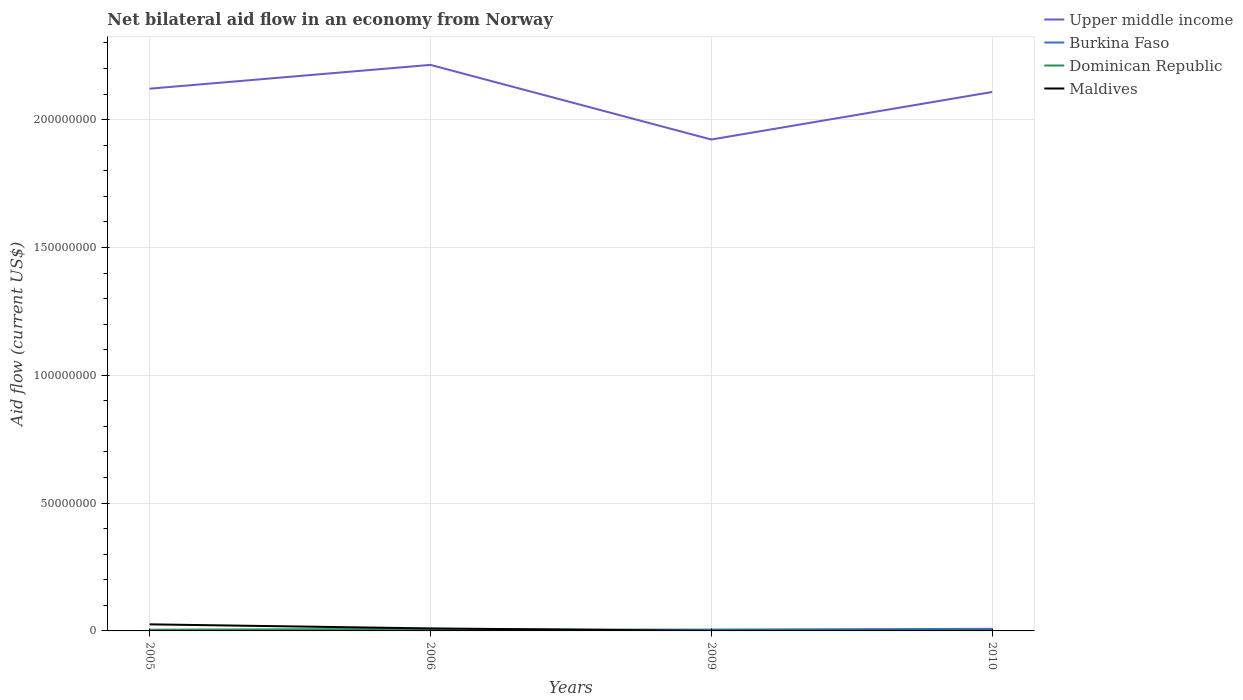How many different coloured lines are there?
Provide a short and direct response. 4. Does the line corresponding to Upper middle income intersect with the line corresponding to Dominican Republic?
Your response must be concise. No. Is the number of lines equal to the number of legend labels?
Keep it short and to the point. Yes. What is the difference between the highest and the second highest net bilateral aid flow in Maldives?
Make the answer very short. 2.56e+06. Is the net bilateral aid flow in Dominican Republic strictly greater than the net bilateral aid flow in Maldives over the years?
Keep it short and to the point. No. How many lines are there?
Give a very brief answer. 4. What is the difference between two consecutive major ticks on the Y-axis?
Give a very brief answer. 5.00e+07. Does the graph contain grids?
Your answer should be very brief. Yes. How many legend labels are there?
Offer a very short reply. 4. What is the title of the graph?
Offer a terse response. Net bilateral aid flow in an economy from Norway. What is the label or title of the Y-axis?
Your response must be concise. Aid flow (current US$). What is the Aid flow (current US$) of Upper middle income in 2005?
Ensure brevity in your answer.  2.12e+08. What is the Aid flow (current US$) of Dominican Republic in 2005?
Your answer should be compact. 4.80e+05. What is the Aid flow (current US$) of Maldives in 2005?
Keep it short and to the point. 2.57e+06. What is the Aid flow (current US$) of Upper middle income in 2006?
Provide a short and direct response. 2.21e+08. What is the Aid flow (current US$) in Burkina Faso in 2006?
Make the answer very short. 3.70e+05. What is the Aid flow (current US$) of Dominican Republic in 2006?
Your response must be concise. 7.90e+05. What is the Aid flow (current US$) of Maldives in 2006?
Keep it short and to the point. 9.80e+05. What is the Aid flow (current US$) in Upper middle income in 2009?
Keep it short and to the point. 1.92e+08. What is the Aid flow (current US$) in Burkina Faso in 2009?
Offer a terse response. 5.30e+05. What is the Aid flow (current US$) of Maldives in 2009?
Keep it short and to the point. 10000. What is the Aid flow (current US$) in Upper middle income in 2010?
Your response must be concise. 2.11e+08. What is the Aid flow (current US$) of Burkina Faso in 2010?
Provide a short and direct response. 8.20e+05. What is the Aid flow (current US$) of Dominican Republic in 2010?
Your response must be concise. 2.60e+05. What is the Aid flow (current US$) of Maldives in 2010?
Your response must be concise. 3.00e+04. Across all years, what is the maximum Aid flow (current US$) of Upper middle income?
Give a very brief answer. 2.21e+08. Across all years, what is the maximum Aid flow (current US$) of Burkina Faso?
Make the answer very short. 8.20e+05. Across all years, what is the maximum Aid flow (current US$) of Dominican Republic?
Make the answer very short. 7.90e+05. Across all years, what is the maximum Aid flow (current US$) of Maldives?
Ensure brevity in your answer.  2.57e+06. Across all years, what is the minimum Aid flow (current US$) of Upper middle income?
Give a very brief answer. 1.92e+08. What is the total Aid flow (current US$) of Upper middle income in the graph?
Your response must be concise. 8.37e+08. What is the total Aid flow (current US$) in Burkina Faso in the graph?
Provide a short and direct response. 1.94e+06. What is the total Aid flow (current US$) of Dominican Republic in the graph?
Your response must be concise. 1.82e+06. What is the total Aid flow (current US$) in Maldives in the graph?
Ensure brevity in your answer.  3.59e+06. What is the difference between the Aid flow (current US$) in Upper middle income in 2005 and that in 2006?
Your response must be concise. -9.31e+06. What is the difference between the Aid flow (current US$) of Dominican Republic in 2005 and that in 2006?
Provide a short and direct response. -3.10e+05. What is the difference between the Aid flow (current US$) in Maldives in 2005 and that in 2006?
Ensure brevity in your answer.  1.59e+06. What is the difference between the Aid flow (current US$) in Upper middle income in 2005 and that in 2009?
Offer a terse response. 1.99e+07. What is the difference between the Aid flow (current US$) of Burkina Faso in 2005 and that in 2009?
Give a very brief answer. -3.10e+05. What is the difference between the Aid flow (current US$) in Maldives in 2005 and that in 2009?
Ensure brevity in your answer.  2.56e+06. What is the difference between the Aid flow (current US$) in Upper middle income in 2005 and that in 2010?
Make the answer very short. 1.29e+06. What is the difference between the Aid flow (current US$) of Burkina Faso in 2005 and that in 2010?
Make the answer very short. -6.00e+05. What is the difference between the Aid flow (current US$) of Maldives in 2005 and that in 2010?
Offer a terse response. 2.54e+06. What is the difference between the Aid flow (current US$) of Upper middle income in 2006 and that in 2009?
Make the answer very short. 2.92e+07. What is the difference between the Aid flow (current US$) of Burkina Faso in 2006 and that in 2009?
Provide a short and direct response. -1.60e+05. What is the difference between the Aid flow (current US$) in Maldives in 2006 and that in 2009?
Provide a short and direct response. 9.70e+05. What is the difference between the Aid flow (current US$) in Upper middle income in 2006 and that in 2010?
Ensure brevity in your answer.  1.06e+07. What is the difference between the Aid flow (current US$) in Burkina Faso in 2006 and that in 2010?
Your answer should be very brief. -4.50e+05. What is the difference between the Aid flow (current US$) in Dominican Republic in 2006 and that in 2010?
Offer a terse response. 5.30e+05. What is the difference between the Aid flow (current US$) in Maldives in 2006 and that in 2010?
Provide a succinct answer. 9.50e+05. What is the difference between the Aid flow (current US$) of Upper middle income in 2009 and that in 2010?
Your answer should be compact. -1.86e+07. What is the difference between the Aid flow (current US$) in Dominican Republic in 2009 and that in 2010?
Provide a succinct answer. 3.00e+04. What is the difference between the Aid flow (current US$) of Upper middle income in 2005 and the Aid flow (current US$) of Burkina Faso in 2006?
Your response must be concise. 2.12e+08. What is the difference between the Aid flow (current US$) in Upper middle income in 2005 and the Aid flow (current US$) in Dominican Republic in 2006?
Your answer should be compact. 2.11e+08. What is the difference between the Aid flow (current US$) in Upper middle income in 2005 and the Aid flow (current US$) in Maldives in 2006?
Provide a short and direct response. 2.11e+08. What is the difference between the Aid flow (current US$) in Burkina Faso in 2005 and the Aid flow (current US$) in Dominican Republic in 2006?
Provide a short and direct response. -5.70e+05. What is the difference between the Aid flow (current US$) of Burkina Faso in 2005 and the Aid flow (current US$) of Maldives in 2006?
Ensure brevity in your answer.  -7.60e+05. What is the difference between the Aid flow (current US$) of Dominican Republic in 2005 and the Aid flow (current US$) of Maldives in 2006?
Offer a very short reply. -5.00e+05. What is the difference between the Aid flow (current US$) of Upper middle income in 2005 and the Aid flow (current US$) of Burkina Faso in 2009?
Give a very brief answer. 2.12e+08. What is the difference between the Aid flow (current US$) of Upper middle income in 2005 and the Aid flow (current US$) of Dominican Republic in 2009?
Your answer should be compact. 2.12e+08. What is the difference between the Aid flow (current US$) in Upper middle income in 2005 and the Aid flow (current US$) in Maldives in 2009?
Offer a very short reply. 2.12e+08. What is the difference between the Aid flow (current US$) of Burkina Faso in 2005 and the Aid flow (current US$) of Dominican Republic in 2009?
Keep it short and to the point. -7.00e+04. What is the difference between the Aid flow (current US$) of Burkina Faso in 2005 and the Aid flow (current US$) of Maldives in 2009?
Provide a succinct answer. 2.10e+05. What is the difference between the Aid flow (current US$) in Dominican Republic in 2005 and the Aid flow (current US$) in Maldives in 2009?
Provide a short and direct response. 4.70e+05. What is the difference between the Aid flow (current US$) of Upper middle income in 2005 and the Aid flow (current US$) of Burkina Faso in 2010?
Make the answer very short. 2.11e+08. What is the difference between the Aid flow (current US$) in Upper middle income in 2005 and the Aid flow (current US$) in Dominican Republic in 2010?
Offer a terse response. 2.12e+08. What is the difference between the Aid flow (current US$) in Upper middle income in 2005 and the Aid flow (current US$) in Maldives in 2010?
Provide a short and direct response. 2.12e+08. What is the difference between the Aid flow (current US$) of Burkina Faso in 2005 and the Aid flow (current US$) of Dominican Republic in 2010?
Your answer should be compact. -4.00e+04. What is the difference between the Aid flow (current US$) in Burkina Faso in 2005 and the Aid flow (current US$) in Maldives in 2010?
Your answer should be very brief. 1.90e+05. What is the difference between the Aid flow (current US$) in Upper middle income in 2006 and the Aid flow (current US$) in Burkina Faso in 2009?
Make the answer very short. 2.21e+08. What is the difference between the Aid flow (current US$) of Upper middle income in 2006 and the Aid flow (current US$) of Dominican Republic in 2009?
Make the answer very short. 2.21e+08. What is the difference between the Aid flow (current US$) of Upper middle income in 2006 and the Aid flow (current US$) of Maldives in 2009?
Offer a terse response. 2.21e+08. What is the difference between the Aid flow (current US$) in Dominican Republic in 2006 and the Aid flow (current US$) in Maldives in 2009?
Provide a short and direct response. 7.80e+05. What is the difference between the Aid flow (current US$) in Upper middle income in 2006 and the Aid flow (current US$) in Burkina Faso in 2010?
Your answer should be very brief. 2.21e+08. What is the difference between the Aid flow (current US$) of Upper middle income in 2006 and the Aid flow (current US$) of Dominican Republic in 2010?
Your response must be concise. 2.21e+08. What is the difference between the Aid flow (current US$) in Upper middle income in 2006 and the Aid flow (current US$) in Maldives in 2010?
Ensure brevity in your answer.  2.21e+08. What is the difference between the Aid flow (current US$) in Burkina Faso in 2006 and the Aid flow (current US$) in Dominican Republic in 2010?
Provide a succinct answer. 1.10e+05. What is the difference between the Aid flow (current US$) in Dominican Republic in 2006 and the Aid flow (current US$) in Maldives in 2010?
Offer a very short reply. 7.60e+05. What is the difference between the Aid flow (current US$) of Upper middle income in 2009 and the Aid flow (current US$) of Burkina Faso in 2010?
Give a very brief answer. 1.91e+08. What is the difference between the Aid flow (current US$) in Upper middle income in 2009 and the Aid flow (current US$) in Dominican Republic in 2010?
Give a very brief answer. 1.92e+08. What is the difference between the Aid flow (current US$) in Upper middle income in 2009 and the Aid flow (current US$) in Maldives in 2010?
Give a very brief answer. 1.92e+08. What is the difference between the Aid flow (current US$) in Burkina Faso in 2009 and the Aid flow (current US$) in Dominican Republic in 2010?
Keep it short and to the point. 2.70e+05. What is the difference between the Aid flow (current US$) of Burkina Faso in 2009 and the Aid flow (current US$) of Maldives in 2010?
Your response must be concise. 5.00e+05. What is the difference between the Aid flow (current US$) in Dominican Republic in 2009 and the Aid flow (current US$) in Maldives in 2010?
Make the answer very short. 2.60e+05. What is the average Aid flow (current US$) of Upper middle income per year?
Provide a short and direct response. 2.09e+08. What is the average Aid flow (current US$) in Burkina Faso per year?
Your response must be concise. 4.85e+05. What is the average Aid flow (current US$) of Dominican Republic per year?
Offer a terse response. 4.55e+05. What is the average Aid flow (current US$) of Maldives per year?
Offer a very short reply. 8.98e+05. In the year 2005, what is the difference between the Aid flow (current US$) of Upper middle income and Aid flow (current US$) of Burkina Faso?
Offer a terse response. 2.12e+08. In the year 2005, what is the difference between the Aid flow (current US$) in Upper middle income and Aid flow (current US$) in Dominican Republic?
Give a very brief answer. 2.12e+08. In the year 2005, what is the difference between the Aid flow (current US$) in Upper middle income and Aid flow (current US$) in Maldives?
Your answer should be compact. 2.10e+08. In the year 2005, what is the difference between the Aid flow (current US$) in Burkina Faso and Aid flow (current US$) in Maldives?
Your answer should be compact. -2.35e+06. In the year 2005, what is the difference between the Aid flow (current US$) in Dominican Republic and Aid flow (current US$) in Maldives?
Your answer should be very brief. -2.09e+06. In the year 2006, what is the difference between the Aid flow (current US$) of Upper middle income and Aid flow (current US$) of Burkina Faso?
Give a very brief answer. 2.21e+08. In the year 2006, what is the difference between the Aid flow (current US$) of Upper middle income and Aid flow (current US$) of Dominican Republic?
Provide a succinct answer. 2.21e+08. In the year 2006, what is the difference between the Aid flow (current US$) of Upper middle income and Aid flow (current US$) of Maldives?
Provide a short and direct response. 2.20e+08. In the year 2006, what is the difference between the Aid flow (current US$) of Burkina Faso and Aid flow (current US$) of Dominican Republic?
Your response must be concise. -4.20e+05. In the year 2006, what is the difference between the Aid flow (current US$) of Burkina Faso and Aid flow (current US$) of Maldives?
Make the answer very short. -6.10e+05. In the year 2009, what is the difference between the Aid flow (current US$) in Upper middle income and Aid flow (current US$) in Burkina Faso?
Keep it short and to the point. 1.92e+08. In the year 2009, what is the difference between the Aid flow (current US$) in Upper middle income and Aid flow (current US$) in Dominican Republic?
Your response must be concise. 1.92e+08. In the year 2009, what is the difference between the Aid flow (current US$) in Upper middle income and Aid flow (current US$) in Maldives?
Offer a very short reply. 1.92e+08. In the year 2009, what is the difference between the Aid flow (current US$) of Burkina Faso and Aid flow (current US$) of Dominican Republic?
Your answer should be compact. 2.40e+05. In the year 2009, what is the difference between the Aid flow (current US$) in Burkina Faso and Aid flow (current US$) in Maldives?
Provide a short and direct response. 5.20e+05. In the year 2010, what is the difference between the Aid flow (current US$) of Upper middle income and Aid flow (current US$) of Burkina Faso?
Your answer should be very brief. 2.10e+08. In the year 2010, what is the difference between the Aid flow (current US$) of Upper middle income and Aid flow (current US$) of Dominican Republic?
Make the answer very short. 2.11e+08. In the year 2010, what is the difference between the Aid flow (current US$) in Upper middle income and Aid flow (current US$) in Maldives?
Your response must be concise. 2.11e+08. In the year 2010, what is the difference between the Aid flow (current US$) of Burkina Faso and Aid flow (current US$) of Dominican Republic?
Give a very brief answer. 5.60e+05. In the year 2010, what is the difference between the Aid flow (current US$) of Burkina Faso and Aid flow (current US$) of Maldives?
Your answer should be very brief. 7.90e+05. In the year 2010, what is the difference between the Aid flow (current US$) of Dominican Republic and Aid flow (current US$) of Maldives?
Your answer should be compact. 2.30e+05. What is the ratio of the Aid flow (current US$) of Upper middle income in 2005 to that in 2006?
Offer a very short reply. 0.96. What is the ratio of the Aid flow (current US$) of Burkina Faso in 2005 to that in 2006?
Your response must be concise. 0.59. What is the ratio of the Aid flow (current US$) in Dominican Republic in 2005 to that in 2006?
Your answer should be very brief. 0.61. What is the ratio of the Aid flow (current US$) in Maldives in 2005 to that in 2006?
Give a very brief answer. 2.62. What is the ratio of the Aid flow (current US$) of Upper middle income in 2005 to that in 2009?
Provide a short and direct response. 1.1. What is the ratio of the Aid flow (current US$) in Burkina Faso in 2005 to that in 2009?
Your answer should be compact. 0.42. What is the ratio of the Aid flow (current US$) in Dominican Republic in 2005 to that in 2009?
Provide a short and direct response. 1.66. What is the ratio of the Aid flow (current US$) in Maldives in 2005 to that in 2009?
Offer a terse response. 257. What is the ratio of the Aid flow (current US$) in Upper middle income in 2005 to that in 2010?
Provide a short and direct response. 1.01. What is the ratio of the Aid flow (current US$) in Burkina Faso in 2005 to that in 2010?
Make the answer very short. 0.27. What is the ratio of the Aid flow (current US$) in Dominican Republic in 2005 to that in 2010?
Give a very brief answer. 1.85. What is the ratio of the Aid flow (current US$) in Maldives in 2005 to that in 2010?
Offer a terse response. 85.67. What is the ratio of the Aid flow (current US$) in Upper middle income in 2006 to that in 2009?
Your answer should be compact. 1.15. What is the ratio of the Aid flow (current US$) in Burkina Faso in 2006 to that in 2009?
Your answer should be compact. 0.7. What is the ratio of the Aid flow (current US$) in Dominican Republic in 2006 to that in 2009?
Give a very brief answer. 2.72. What is the ratio of the Aid flow (current US$) of Maldives in 2006 to that in 2009?
Provide a succinct answer. 98. What is the ratio of the Aid flow (current US$) in Upper middle income in 2006 to that in 2010?
Keep it short and to the point. 1.05. What is the ratio of the Aid flow (current US$) in Burkina Faso in 2006 to that in 2010?
Provide a succinct answer. 0.45. What is the ratio of the Aid flow (current US$) in Dominican Republic in 2006 to that in 2010?
Offer a terse response. 3.04. What is the ratio of the Aid flow (current US$) of Maldives in 2006 to that in 2010?
Provide a succinct answer. 32.67. What is the ratio of the Aid flow (current US$) in Upper middle income in 2009 to that in 2010?
Give a very brief answer. 0.91. What is the ratio of the Aid flow (current US$) in Burkina Faso in 2009 to that in 2010?
Offer a very short reply. 0.65. What is the ratio of the Aid flow (current US$) in Dominican Republic in 2009 to that in 2010?
Provide a short and direct response. 1.12. What is the ratio of the Aid flow (current US$) of Maldives in 2009 to that in 2010?
Give a very brief answer. 0.33. What is the difference between the highest and the second highest Aid flow (current US$) in Upper middle income?
Keep it short and to the point. 9.31e+06. What is the difference between the highest and the second highest Aid flow (current US$) in Maldives?
Keep it short and to the point. 1.59e+06. What is the difference between the highest and the lowest Aid flow (current US$) of Upper middle income?
Provide a short and direct response. 2.92e+07. What is the difference between the highest and the lowest Aid flow (current US$) of Burkina Faso?
Your answer should be very brief. 6.00e+05. What is the difference between the highest and the lowest Aid flow (current US$) in Dominican Republic?
Give a very brief answer. 5.30e+05. What is the difference between the highest and the lowest Aid flow (current US$) in Maldives?
Your answer should be very brief. 2.56e+06. 